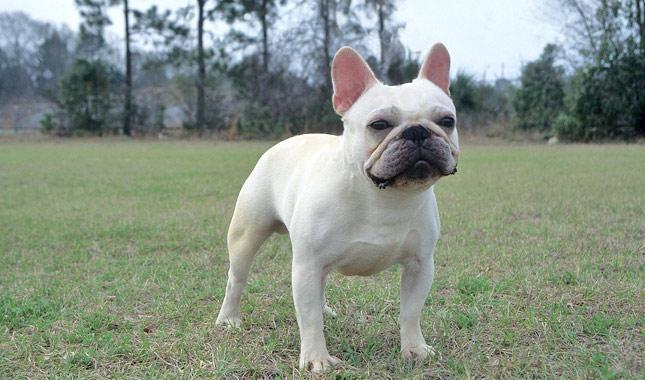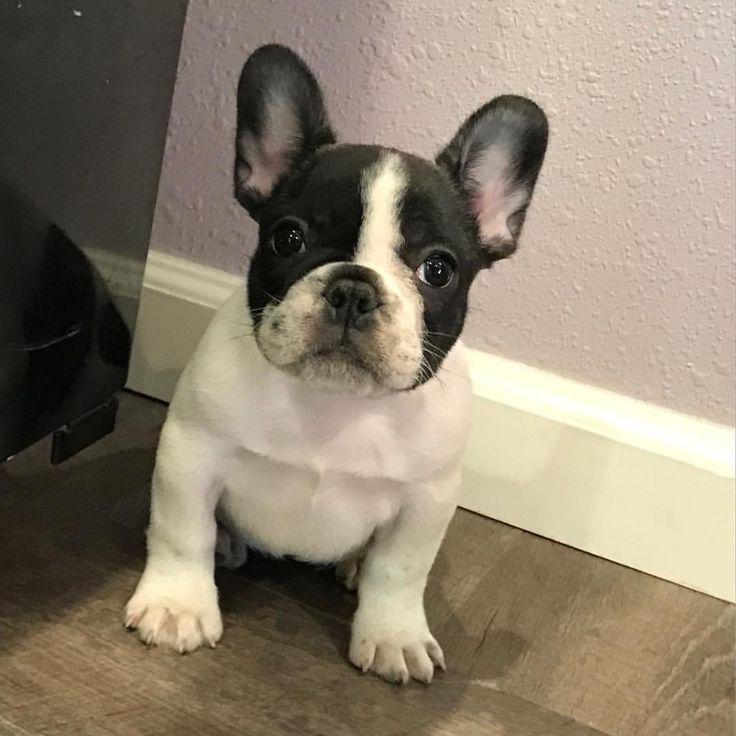The first image is the image on the left, the second image is the image on the right. For the images displayed, is the sentence "There is at least one mostly black dog standing on all four legs in the image on the left." factually correct? Answer yes or no. No. 